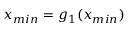Convert formula to latex. <formula><loc_0><loc_0><loc_500><loc_500>x _ { \min } = g _ { 1 } ( x _ { \min } )</formula> 